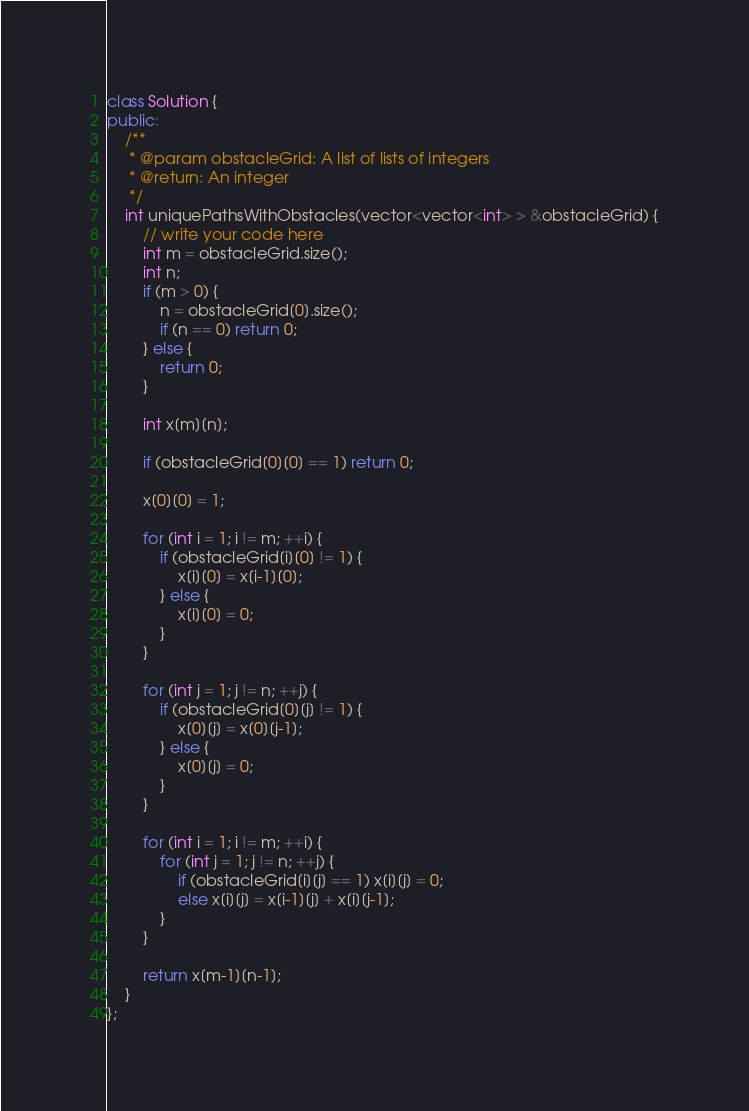<code> <loc_0><loc_0><loc_500><loc_500><_C++_>class Solution {
public:
    /**
     * @param obstacleGrid: A list of lists of integers
     * @return: An integer
     */ 
    int uniquePathsWithObstacles(vector<vector<int> > &obstacleGrid) {
        // write your code here
        int m = obstacleGrid.size();
        int n;
        if (m > 0) {
            n = obstacleGrid[0].size();
            if (n == 0) return 0;
        } else {
            return 0;
        }
        
        int x[m][n];
        
        if (obstacleGrid[0][0] == 1) return 0;
        
        x[0][0] = 1;
        
        for (int i = 1; i != m; ++i) {
            if (obstacleGrid[i][0] != 1) {
                x[i][0] = x[i-1][0];
            } else {
                x[i][0] = 0;
            }
        }
        
        for (int j = 1; j != n; ++j) {
            if (obstacleGrid[0][j] != 1) {
                x[0][j] = x[0][j-1];
            } else {
                x[0][j] = 0;
            }
        }
        
        for (int i = 1; i != m; ++i) {
            for (int j = 1; j != n; ++j) {
                if (obstacleGrid[i][j] == 1) x[i][j] = 0;
                else x[i][j] = x[i-1][j] + x[i][j-1];
            }
        }
        
        return x[m-1][n-1];
    }
};</code> 